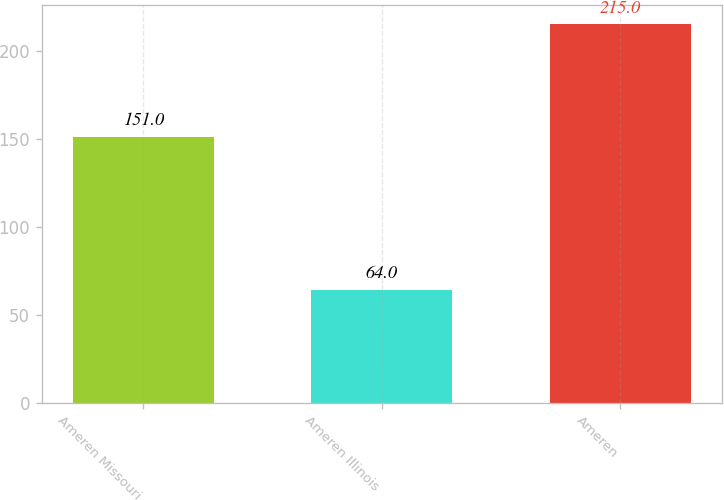Convert chart to OTSL. <chart><loc_0><loc_0><loc_500><loc_500><bar_chart><fcel>Ameren Missouri<fcel>Ameren Illinois<fcel>Ameren<nl><fcel>151<fcel>64<fcel>215<nl></chart> 